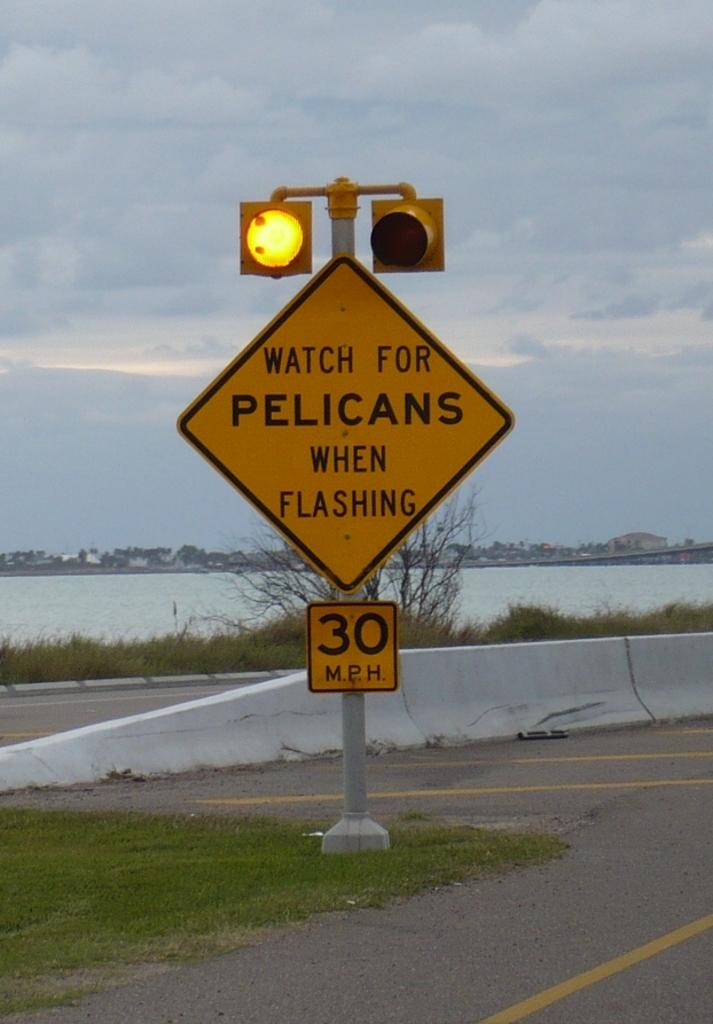What is the speed limit?
Offer a terse response. 30. 